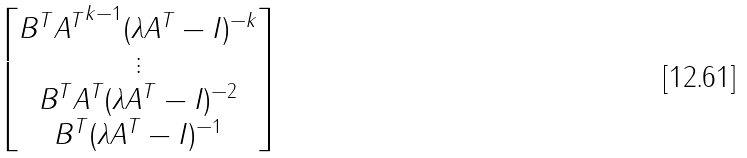<formula> <loc_0><loc_0><loc_500><loc_500>\begin{bmatrix} B ^ { T } { A ^ { T } } ^ { k - 1 } ( \lambda A ^ { T } - I ) ^ { - k } \\ \vdots \\ B ^ { T } A ^ { T } ( \lambda A ^ { T } - I ) ^ { - 2 } \\ B ^ { T } ( \lambda A ^ { T } - I ) ^ { - 1 } \end{bmatrix}</formula> 